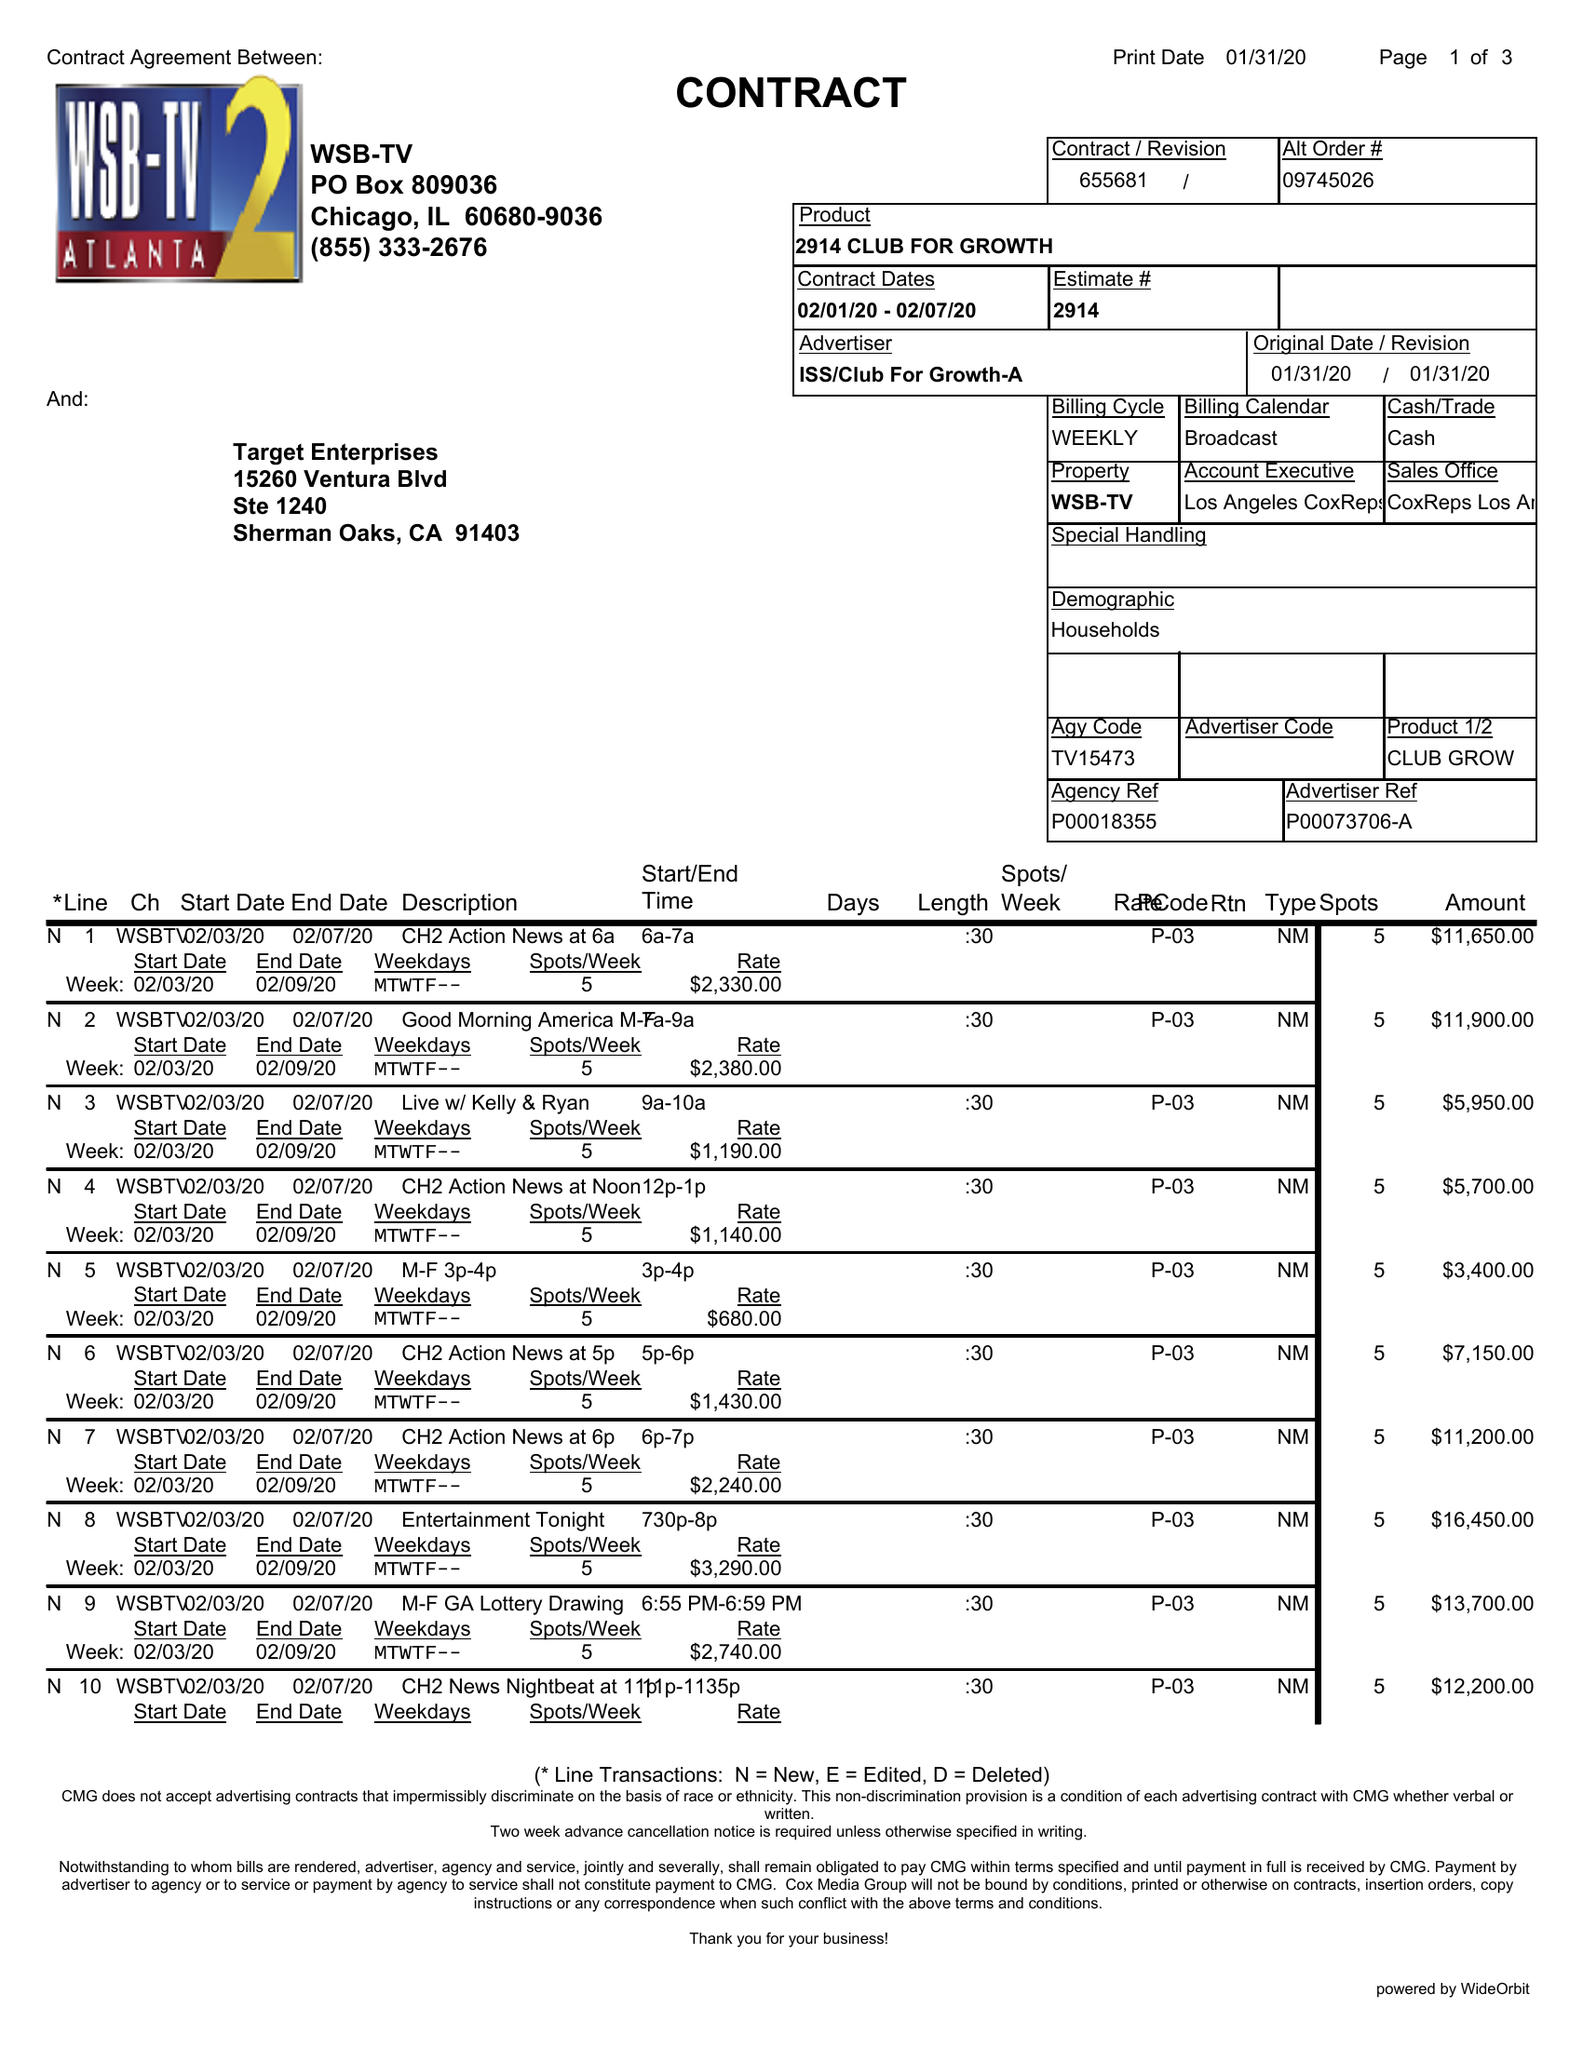What is the value for the gross_amount?
Answer the question using a single word or phrase. 138655.00 